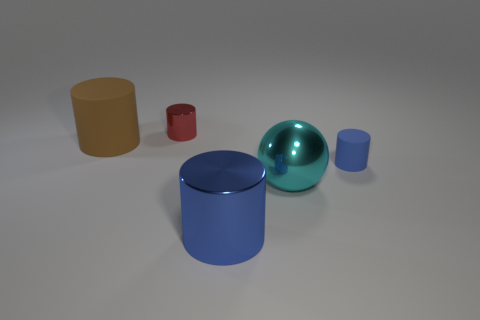Subtract all small red cylinders. How many cylinders are left? 3 Subtract 2 cylinders. How many cylinders are left? 2 Subtract all red cylinders. How many cylinders are left? 3 Add 4 big cyan cubes. How many objects exist? 9 Subtract all cylinders. How many objects are left? 1 Subtract all purple cylinders. How many purple spheres are left? 0 Subtract all big gray cylinders. Subtract all blue rubber cylinders. How many objects are left? 4 Add 3 large brown matte objects. How many large brown matte objects are left? 4 Add 2 blue rubber cylinders. How many blue rubber cylinders exist? 3 Subtract 0 green cylinders. How many objects are left? 5 